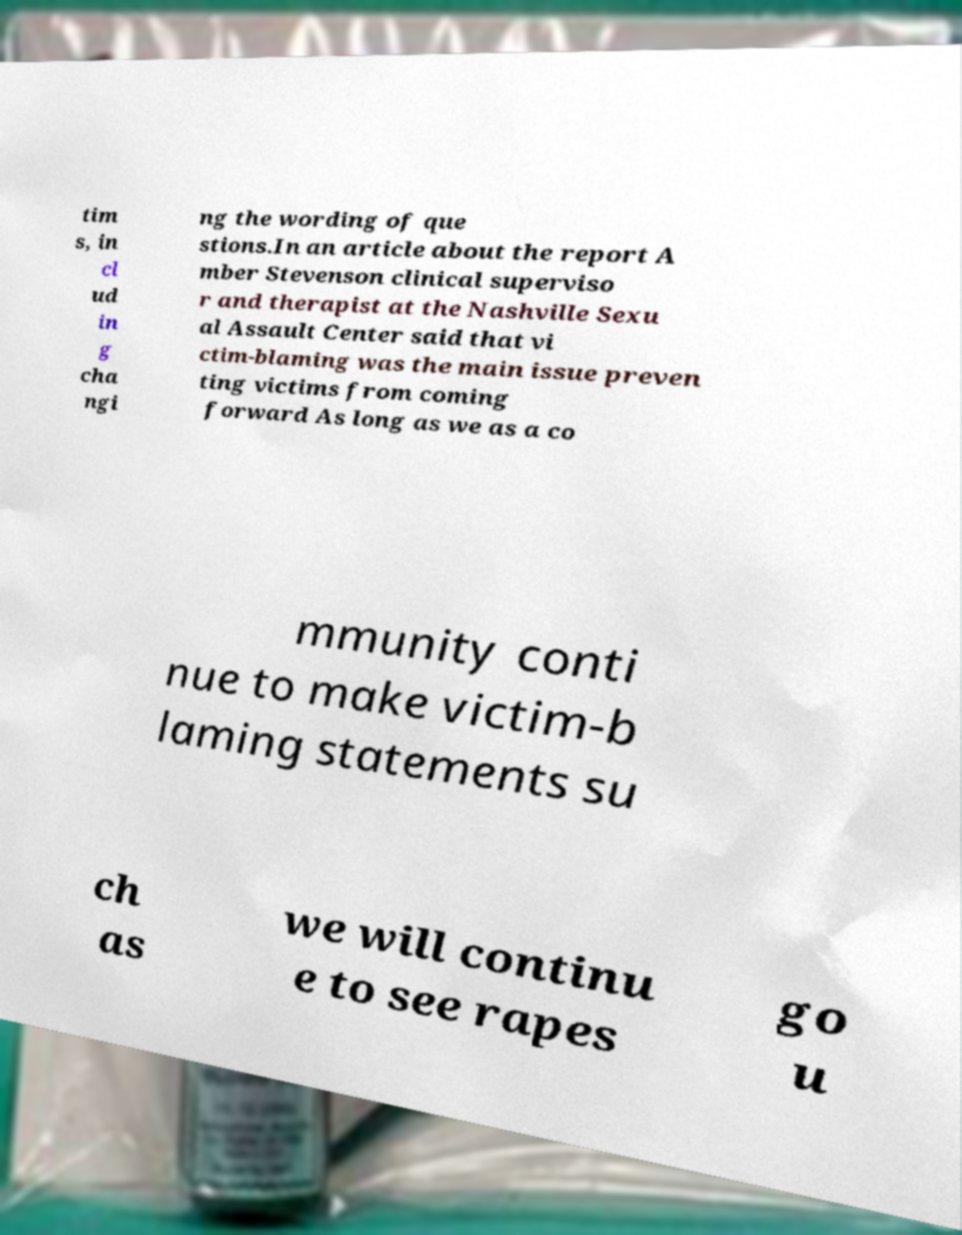I need the written content from this picture converted into text. Can you do that? tim s, in cl ud in g cha ngi ng the wording of que stions.In an article about the report A mber Stevenson clinical superviso r and therapist at the Nashville Sexu al Assault Center said that vi ctim-blaming was the main issue preven ting victims from coming forward As long as we as a co mmunity conti nue to make victim-b laming statements su ch as we will continu e to see rapes go u 